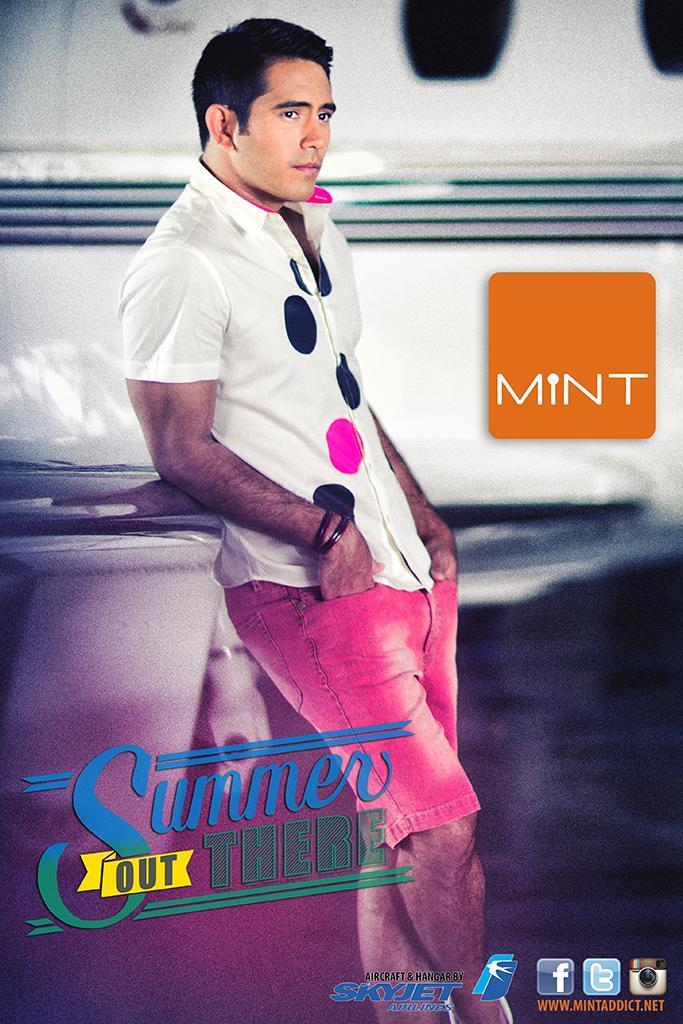How would you summarize this image in a sentence or two? In this image we can see a man is standing, he is wearing a white shirt, the background is white, and there is an orange board. 